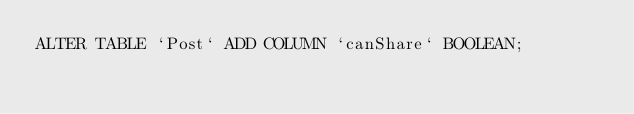Convert code to text. <code><loc_0><loc_0><loc_500><loc_500><_SQL_>ALTER TABLE `Post` ADD COLUMN `canShare` BOOLEAN;
</code> 